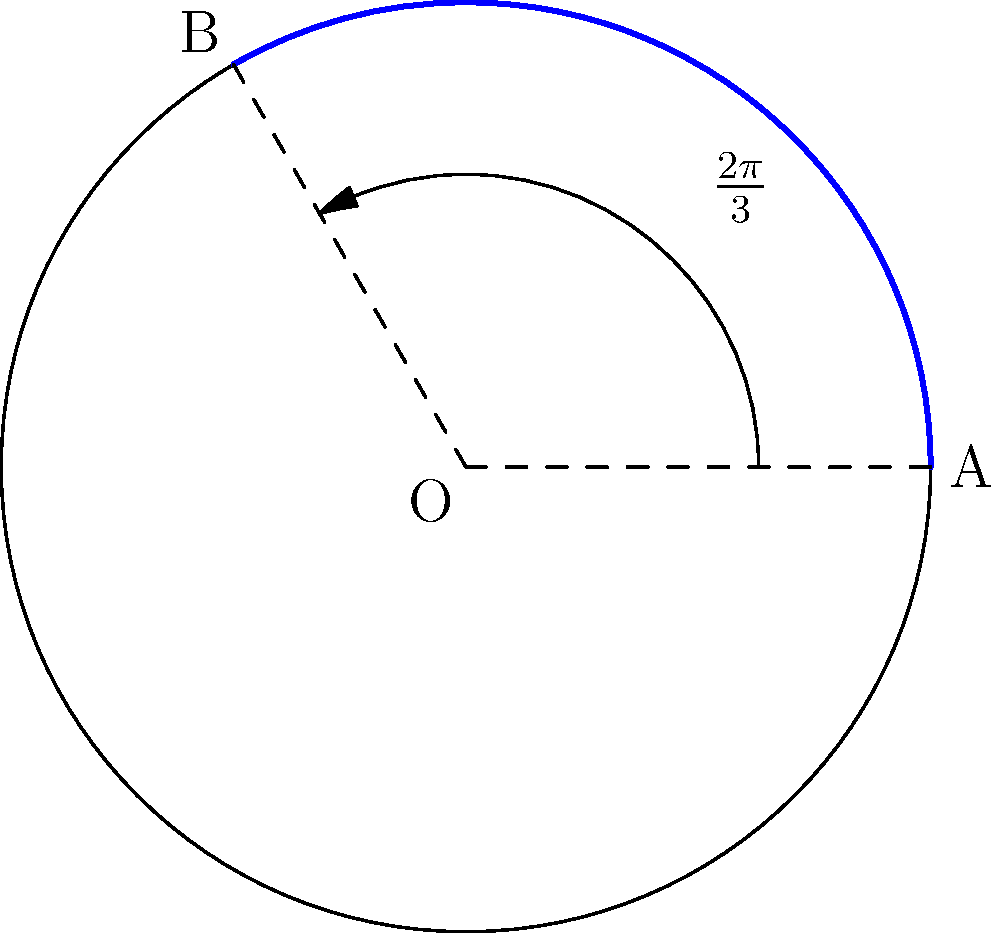During a training flight, a fighter jet's fuel consumption varies depending on the flight phase. The circular diagram represents the total fuel capacity, where the blue sector indicates the fuel consumed during the takeoff and initial climb phase. If the total fuel capacity is 12,000 liters and the central angle of the blue sector is $\frac{2\pi}{3}$ radians, how many liters of fuel are consumed during the takeoff and initial climb phase? Let's approach this step-by-step:

1) The area of a circular sector is given by the formula:
   $$A_{sector} = \frac{1}{2}r^2\theta$$
   where $r$ is the radius and $\theta$ is the central angle in radians.

2) The total area of the circle represents the total fuel capacity (12,000 liters).
   The area of the blue sector represents the fuel consumed during takeoff and initial climb.

3) The ratio of the sector area to the total circle area will be equal to the ratio of fuel consumed to total fuel capacity:

   $$\frac{A_{sector}}{A_{circle}} = \frac{\text{Fuel consumed}}{\text{Total fuel}}$$

4) We can express this as:

   $$\frac{\frac{1}{2}r^2\theta}{\pi r^2} = \frac{\text{Fuel consumed}}{12000}$$

5) The angle $\theta$ is given as $\frac{2\pi}{3}$ radians. Let's substitute this:

   $$\frac{\frac{1}{2}r^2(\frac{2\pi}{3})}{\pi r^2} = \frac{\text{Fuel consumed}}{12000}$$

6) Simplify:

   $$\frac{\frac{\pi r^2}{3}}{\pi r^2} = \frac{\text{Fuel consumed}}{12000}$$

   $$\frac{1}{3} = \frac{\text{Fuel consumed}}{12000}$$

7) Solve for the fuel consumed:

   $$\text{Fuel consumed} = 12000 \times \frac{1}{3} = 4000$$

Therefore, 4000 liters of fuel are consumed during the takeoff and initial climb phase.
Answer: 4000 liters 